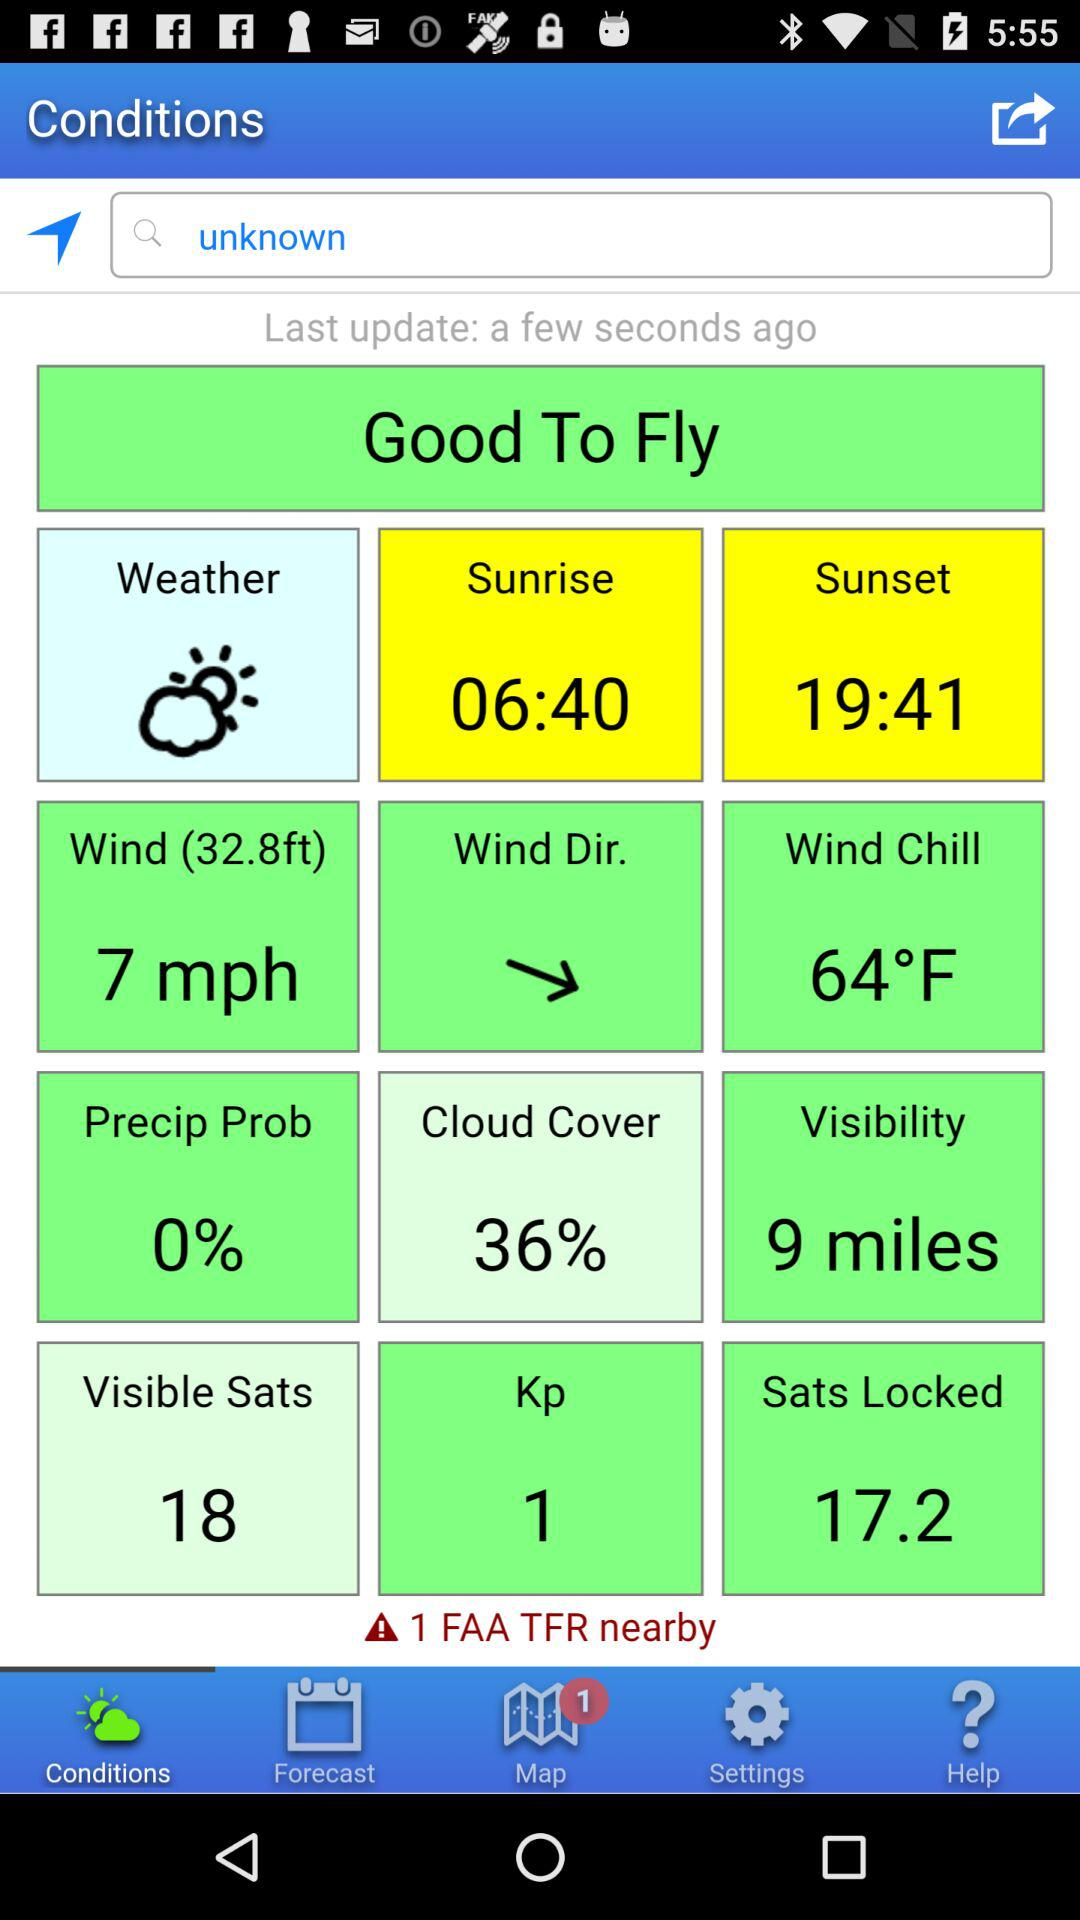How many FAA TFRs are nearby?
Answer the question using a single word or phrase. 1 